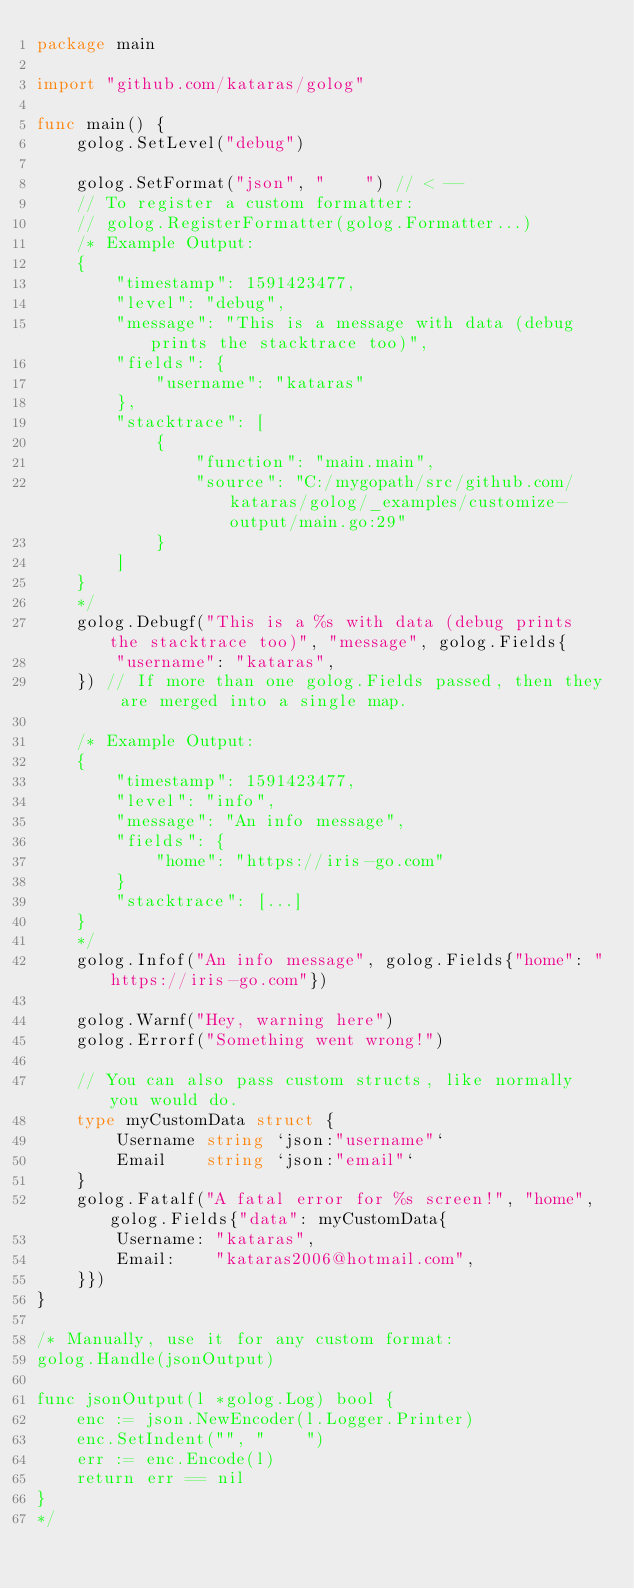<code> <loc_0><loc_0><loc_500><loc_500><_Go_>package main

import "github.com/kataras/golog"

func main() {
	golog.SetLevel("debug")

	golog.SetFormat("json", "    ") // < --
	// To register a custom formatter:
	// golog.RegisterFormatter(golog.Formatter...)
	/* Example Output:
	{
	    "timestamp": 1591423477,
	    "level": "debug",
	    "message": "This is a message with data (debug prints the stacktrace too)",
	    "fields": {
	        "username": "kataras"
	    },
	    "stacktrace": [
	        {
	            "function": "main.main",
	            "source": "C:/mygopath/src/github.com/kataras/golog/_examples/customize-output/main.go:29"
	        }
	    ]
	}
	*/
	golog.Debugf("This is a %s with data (debug prints the stacktrace too)", "message", golog.Fields{
		"username": "kataras",
	}) // If more than one golog.Fields passed, then they are merged into a single map.

	/* Example Output:
	{
	    "timestamp": 1591423477,
	    "level": "info",
	    "message": "An info message",
	    "fields": {
	        "home": "https://iris-go.com"
	    }
		"stacktrace": [...]
	}
	*/
	golog.Infof("An info message", golog.Fields{"home": "https://iris-go.com"})

	golog.Warnf("Hey, warning here")
	golog.Errorf("Something went wrong!")

	// You can also pass custom structs, like normally you would do.
	type myCustomData struct {
		Username string `json:"username"`
		Email    string `json:"email"`
	}
	golog.Fatalf("A fatal error for %s screen!", "home", golog.Fields{"data": myCustomData{
		Username: "kataras",
		Email:    "kataras2006@hotmail.com",
	}})
}

/* Manually, use it for any custom format:
golog.Handle(jsonOutput)

func jsonOutput(l *golog.Log) bool {
	enc := json.NewEncoder(l.Logger.Printer)
	enc.SetIndent("", "    ")
	err := enc.Encode(l)
	return err == nil
}
*/
</code> 